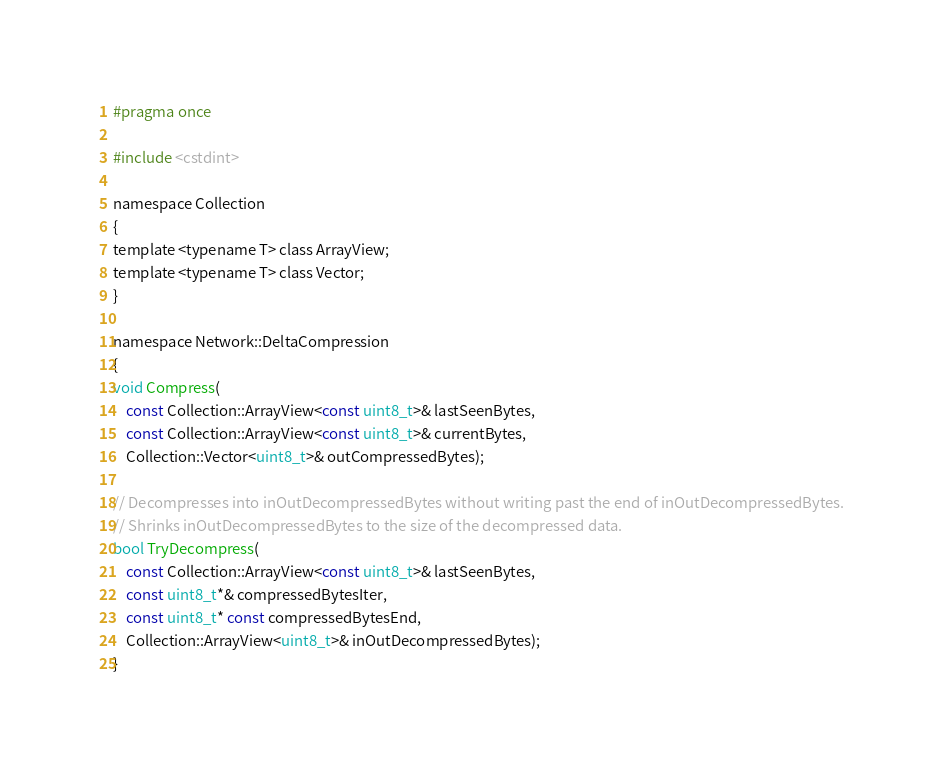Convert code to text. <code><loc_0><loc_0><loc_500><loc_500><_C_>#pragma once

#include <cstdint>

namespace Collection
{
template <typename T> class ArrayView;
template <typename T> class Vector;
}

namespace Network::DeltaCompression
{
void Compress(
	const Collection::ArrayView<const uint8_t>& lastSeenBytes,
	const Collection::ArrayView<const uint8_t>& currentBytes,
	Collection::Vector<uint8_t>& outCompressedBytes);

// Decompresses into inOutDecompressedBytes without writing past the end of inOutDecompressedBytes.
// Shrinks inOutDecompressedBytes to the size of the decompressed data.
bool TryDecompress(
	const Collection::ArrayView<const uint8_t>& lastSeenBytes,
	const uint8_t*& compressedBytesIter,
	const uint8_t* const compressedBytesEnd,
	Collection::ArrayView<uint8_t>& inOutDecompressedBytes);
}
</code> 